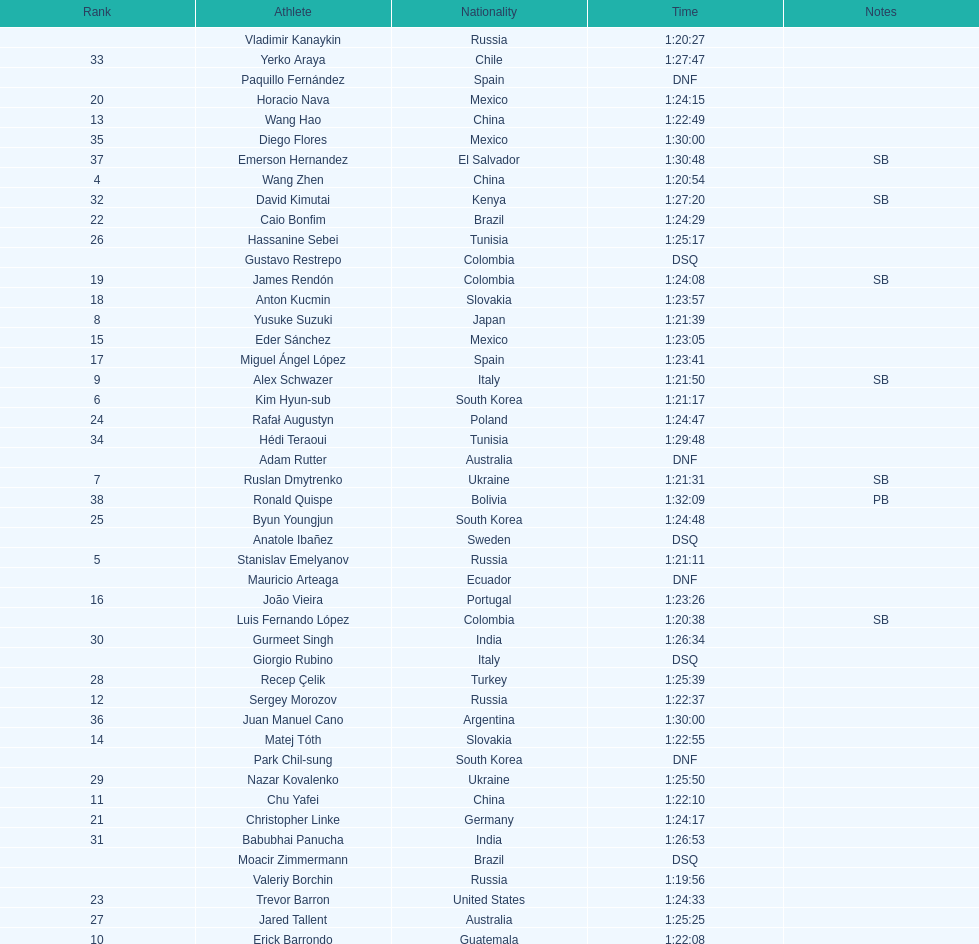Name all athletes were slower than horacio nava. Christopher Linke, Caio Bonfim, Trevor Barron, Rafał Augustyn, Byun Youngjun, Hassanine Sebei, Jared Tallent, Recep Çelik, Nazar Kovalenko, Gurmeet Singh, Babubhai Panucha, David Kimutai, Yerko Araya, Hédi Teraoui, Diego Flores, Juan Manuel Cano, Emerson Hernandez, Ronald Quispe. 